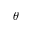Convert formula to latex. <formula><loc_0><loc_0><loc_500><loc_500>\theta</formula> 